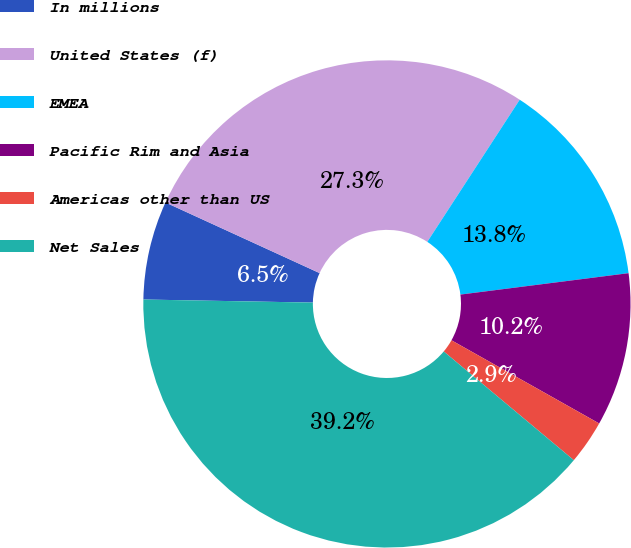Convert chart to OTSL. <chart><loc_0><loc_0><loc_500><loc_500><pie_chart><fcel>In millions<fcel>United States (f)<fcel>EMEA<fcel>Pacific Rim and Asia<fcel>Americas other than US<fcel>Net Sales<nl><fcel>6.55%<fcel>27.34%<fcel>13.81%<fcel>10.18%<fcel>2.92%<fcel>39.21%<nl></chart> 